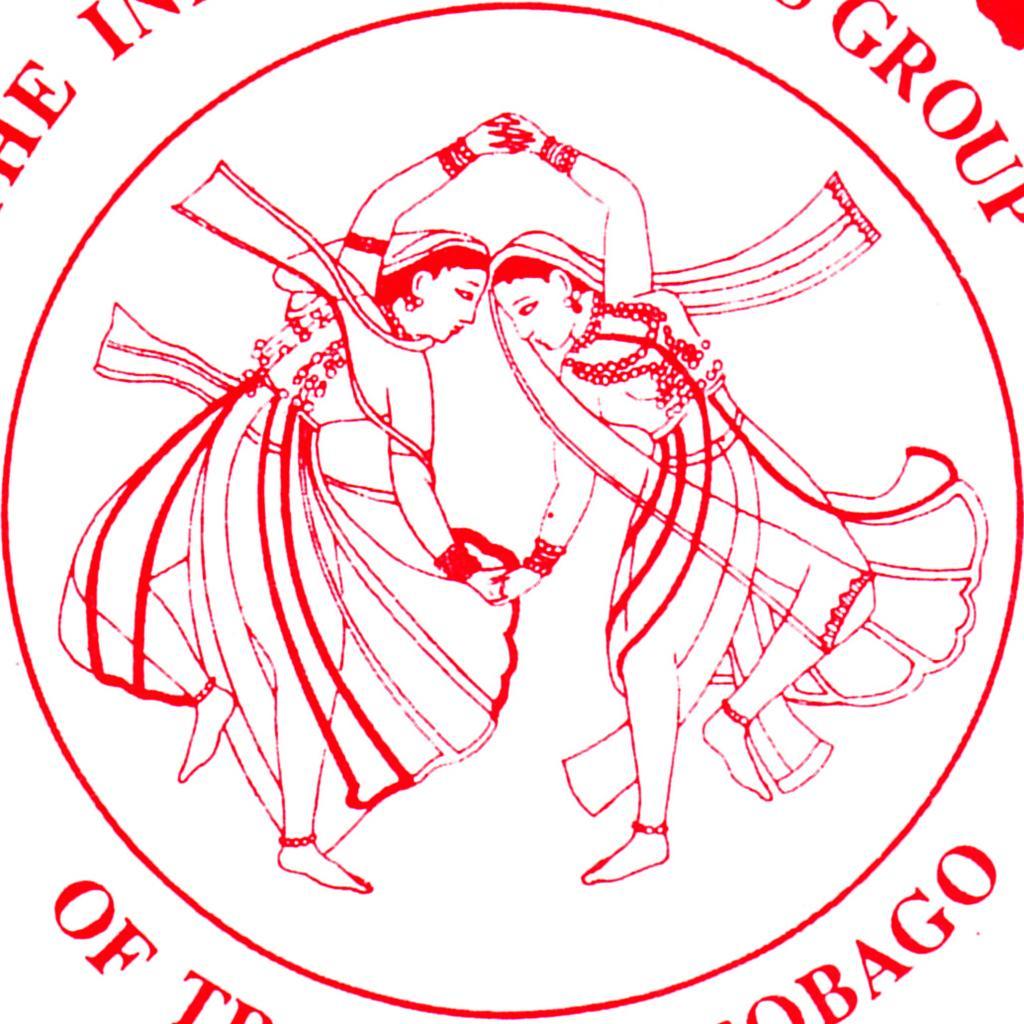In one or two sentences, can you explain what this image depicts? In this picture we can see a logo and some text, here we can see depictions of two persons in the middle. 